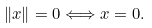Convert formula to latex. <formula><loc_0><loc_0><loc_500><loc_500>\| x \| = 0 \Longleftrightarrow x = 0 .</formula> 